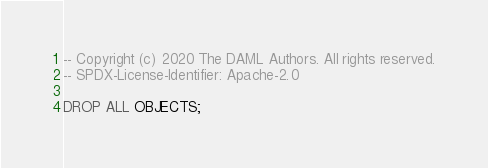<code> <loc_0><loc_0><loc_500><loc_500><_SQL_>-- Copyright (c) 2020 The DAML Authors. All rights reserved.
-- SPDX-License-Identifier: Apache-2.0

DROP ALL OBJECTS;
</code> 